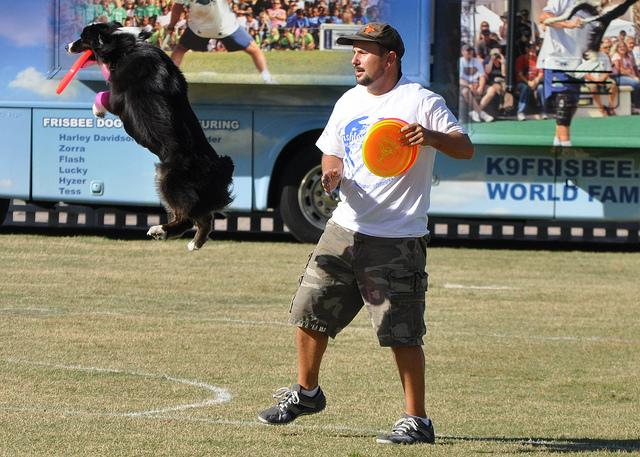Why did the dog jump in the air?

Choices:
A) eat
B) catch
C) flip
D) greet catch 